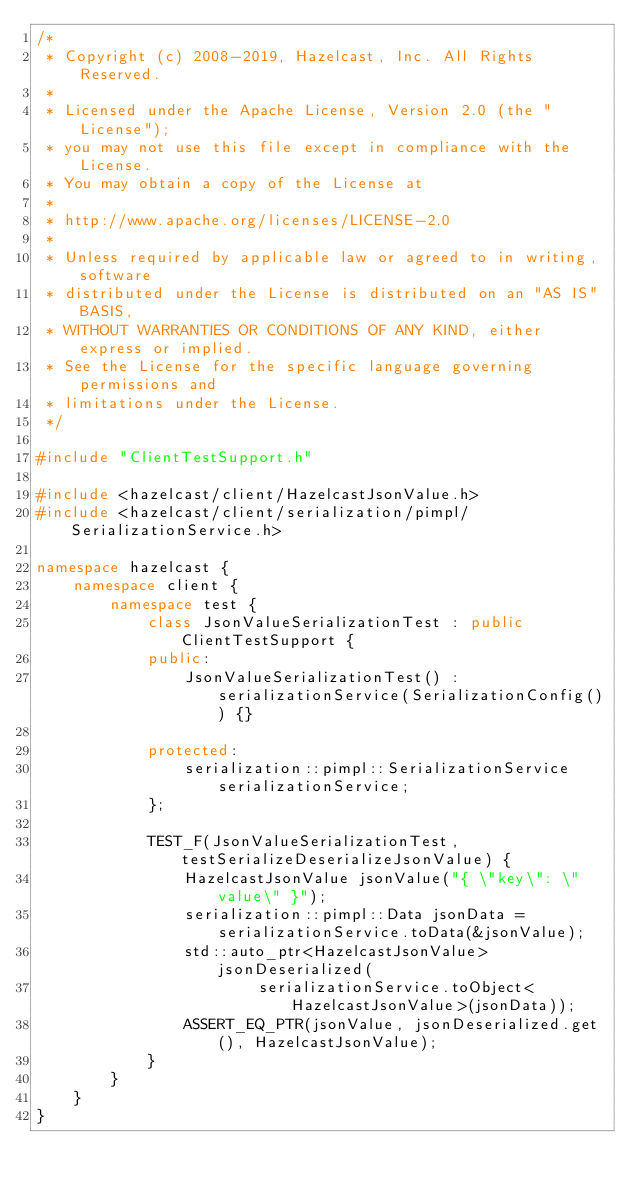<code> <loc_0><loc_0><loc_500><loc_500><_C++_>/*
 * Copyright (c) 2008-2019, Hazelcast, Inc. All Rights Reserved.
 *
 * Licensed under the Apache License, Version 2.0 (the "License");
 * you may not use this file except in compliance with the License.
 * You may obtain a copy of the License at
 *
 * http://www.apache.org/licenses/LICENSE-2.0
 *
 * Unless required by applicable law or agreed to in writing, software
 * distributed under the License is distributed on an "AS IS" BASIS,
 * WITHOUT WARRANTIES OR CONDITIONS OF ANY KIND, either express or implied.
 * See the License for the specific language governing permissions and
 * limitations under the License.
 */

#include "ClientTestSupport.h"

#include <hazelcast/client/HazelcastJsonValue.h>
#include <hazelcast/client/serialization/pimpl/SerializationService.h>

namespace hazelcast {
    namespace client {
        namespace test {
            class JsonValueSerializationTest : public ClientTestSupport {
            public:
                JsonValueSerializationTest() : serializationService(SerializationConfig()) {}

            protected:
                serialization::pimpl::SerializationService serializationService;
            };

            TEST_F(JsonValueSerializationTest, testSerializeDeserializeJsonValue) {
                HazelcastJsonValue jsonValue("{ \"key\": \"value\" }");
                serialization::pimpl::Data jsonData = serializationService.toData(&jsonValue);
                std::auto_ptr<HazelcastJsonValue> jsonDeserialized(
                        serializationService.toObject<HazelcastJsonValue>(jsonData));
                ASSERT_EQ_PTR(jsonValue, jsonDeserialized.get(), HazelcastJsonValue);
            }
        }
    }
}
</code> 